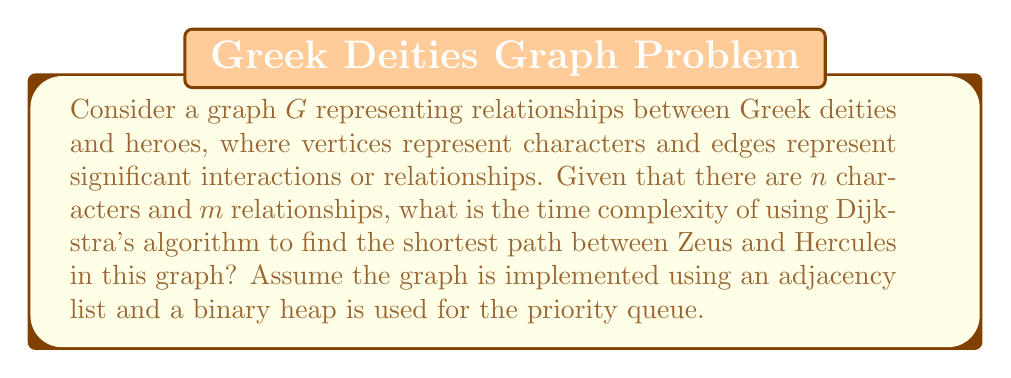Give your solution to this math problem. To analyze the time complexity of Dijkstra's algorithm in this context, we need to consider the following steps:

1. Initialization:
   - Creating the priority queue: $O(n)$
   - Setting initial distances: $O(n)$

2. Main loop:
   - The main loop runs for each vertex: $O(n)$
   - For each vertex, we perform the following operations:
     a. Extract minimum from the priority queue: $O(\log n)$
     b. Update distances for adjacent vertices: $O(\deg(v) \cdot \log n)$

   Where $\deg(v)$ is the degree of vertex $v$ (number of adjacent vertices).

3. Total complexity:
   The total time complexity is the sum of initialization and the main loop operations:

   $$O(n + n + n \log n + \sum_{v \in V} \deg(v) \log n)$$

   We can simplify this expression:
   - $\sum_{v \in V} \deg(v) = 2m$ (sum of degrees equals twice the number of edges)
   - The dominating terms are $n \log n$ and $m \log n$

   Therefore, the overall time complexity is:

   $$O((n + m) \log n)$$

In the context of Greek mythology, $n$ would represent the number of deities and heroes, while $m$ would represent the number of relationships or interactions between them. This complexity allows for efficient pathfinding between characters like Zeus and Hercules in the mythological network.
Answer: The time complexity of using Dijkstra's algorithm to find the shortest path between Zeus and Hercules in a graph representing Greek mythological characters and their relationships is $O((n + m) \log n)$, where $n$ is the number of characters and $m$ is the number of relationships. 